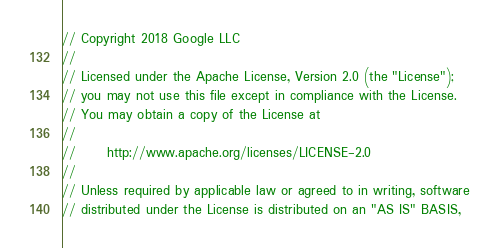Convert code to text. <code><loc_0><loc_0><loc_500><loc_500><_Java_>// Copyright 2018 Google LLC
//
// Licensed under the Apache License, Version 2.0 (the "License");
// you may not use this file except in compliance with the License.
// You may obtain a copy of the License at
//
//      http://www.apache.org/licenses/LICENSE-2.0
//
// Unless required by applicable law or agreed to in writing, software
// distributed under the License is distributed on an "AS IS" BASIS,</code> 